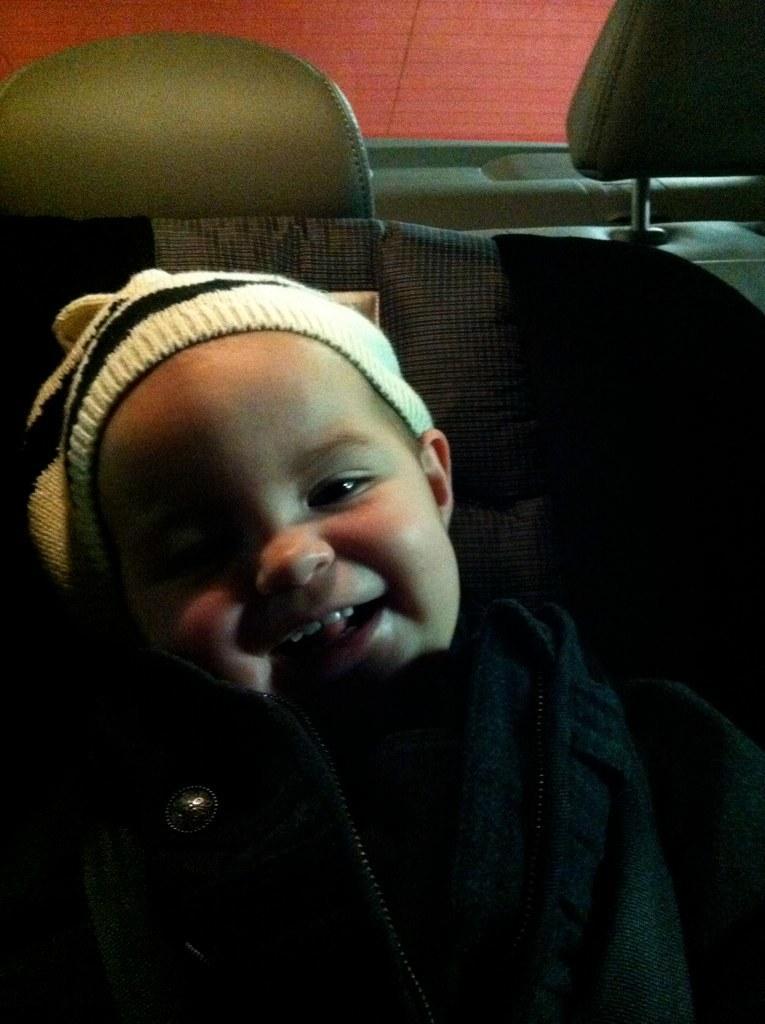Describe this image in one or two sentences. In the image we can see a baby wearing clothes and a cap, and the baby is smiling. These are the seat of the vehicle. 